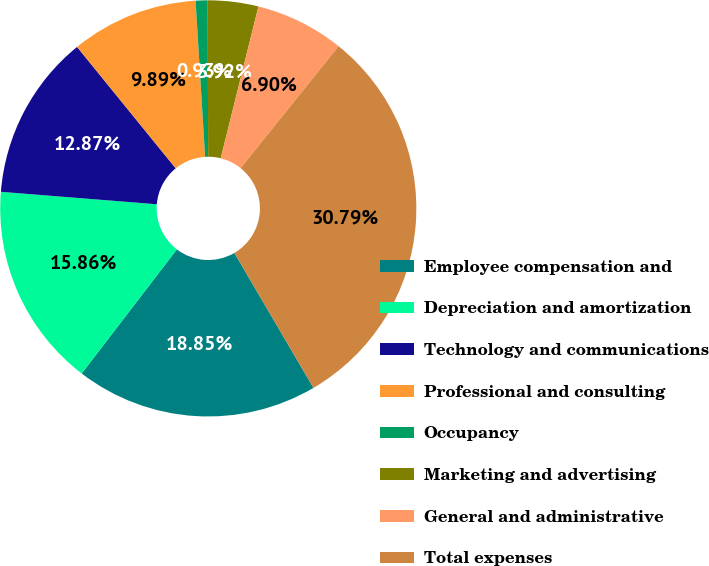Convert chart to OTSL. <chart><loc_0><loc_0><loc_500><loc_500><pie_chart><fcel>Employee compensation and<fcel>Depreciation and amortization<fcel>Technology and communications<fcel>Professional and consulting<fcel>Occupancy<fcel>Marketing and advertising<fcel>General and administrative<fcel>Total expenses<nl><fcel>18.85%<fcel>15.86%<fcel>12.87%<fcel>9.89%<fcel>0.93%<fcel>3.92%<fcel>6.9%<fcel>30.79%<nl></chart> 